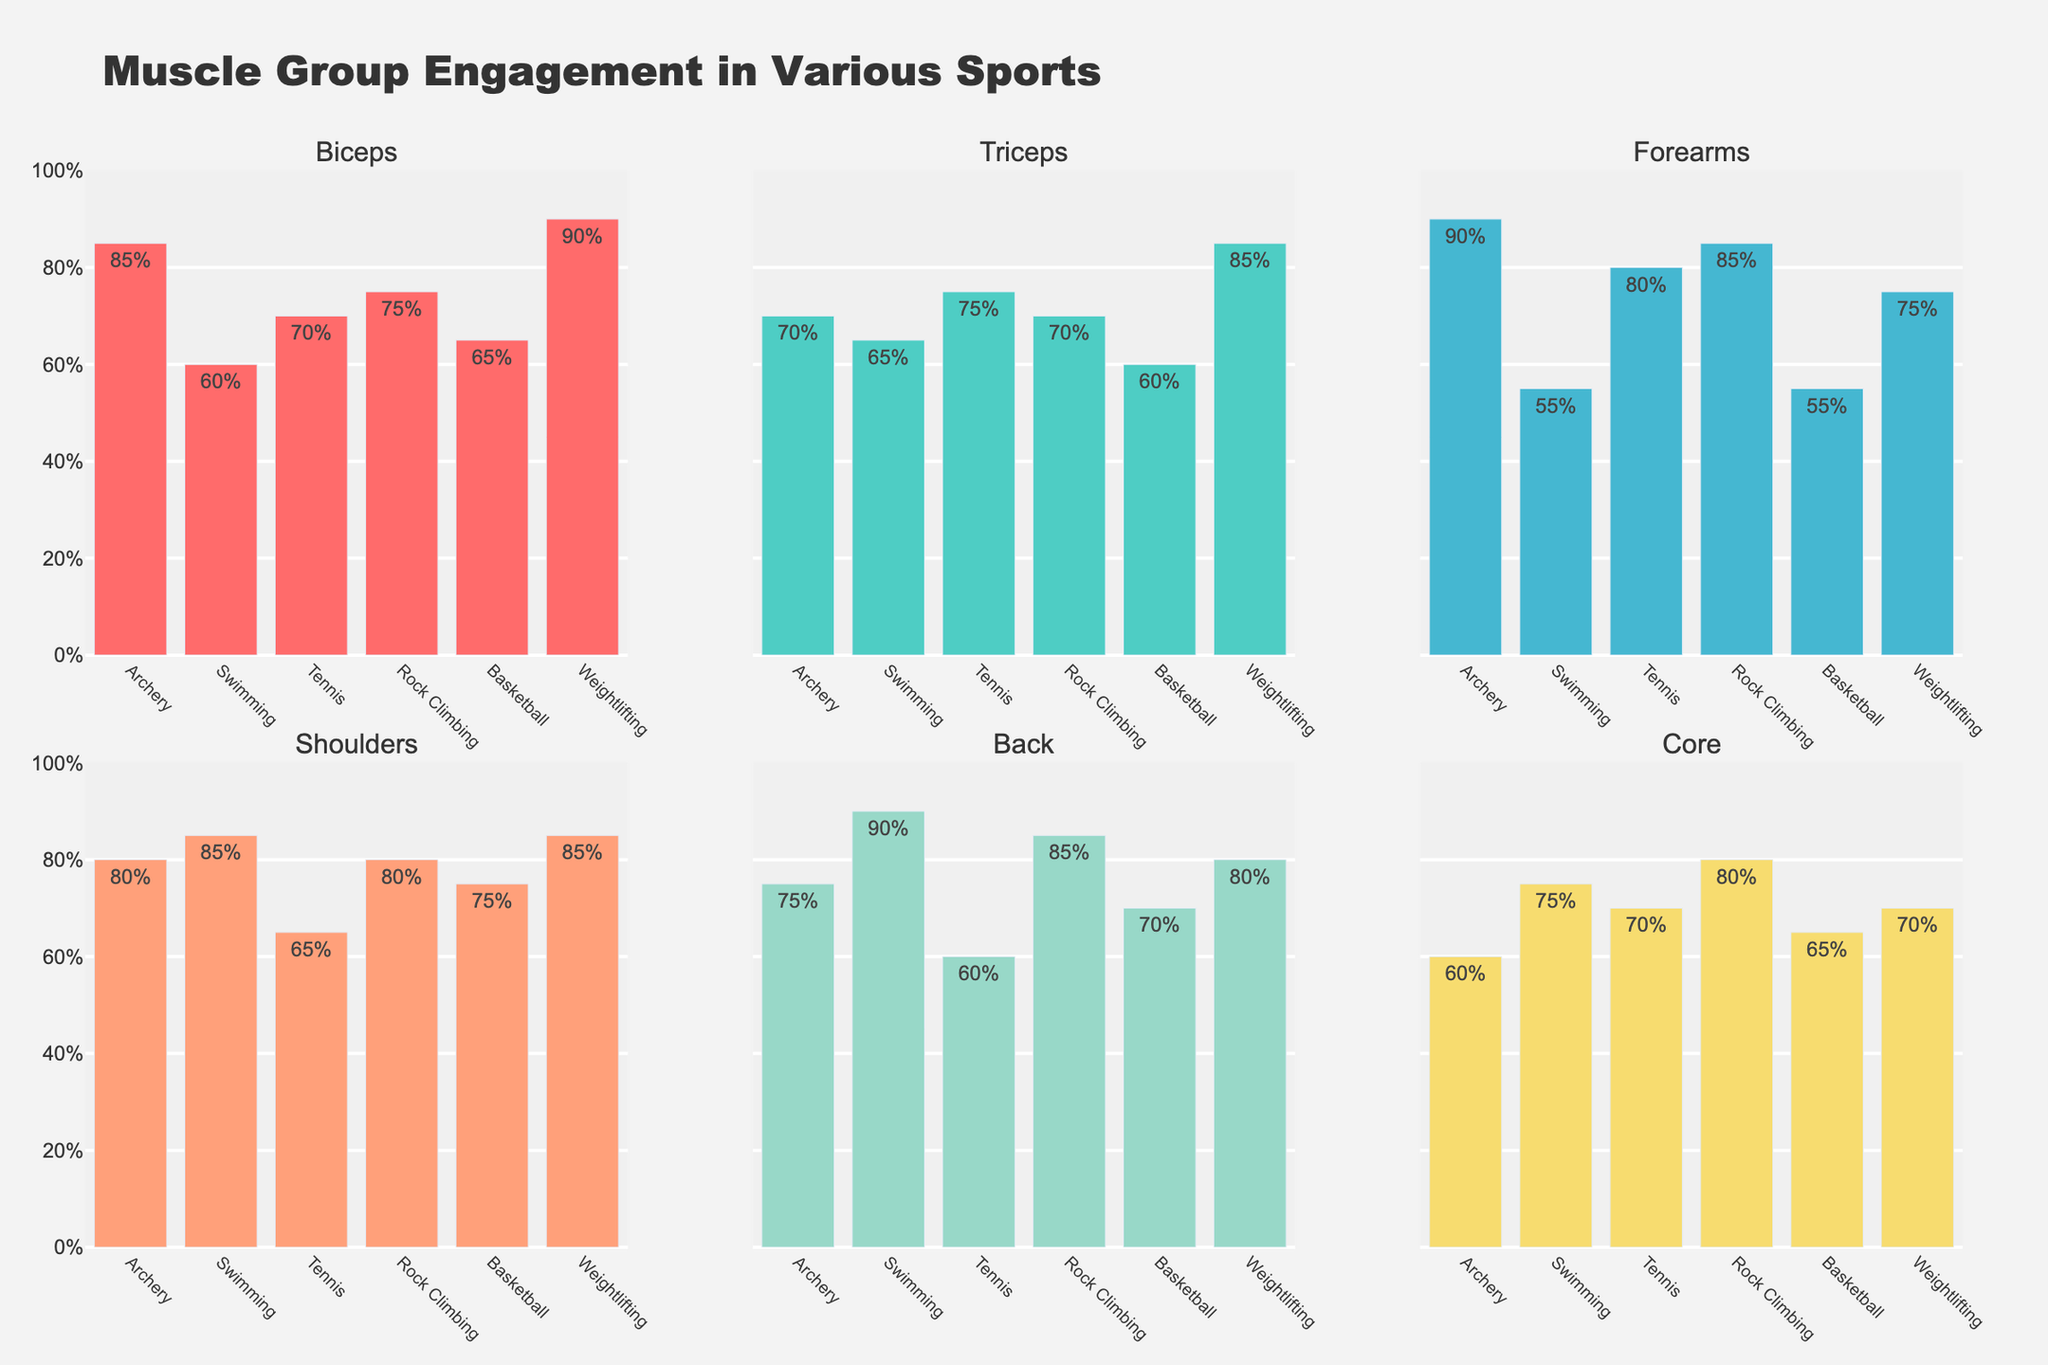What is the title of the figure? The title is located at the top center of the figure, it reads "Weekly Training Regimen for Professional Ballet Dancers"
Answer: Weekly Training Regimen for Professional Ballet Dancers Which activity has the highest number of hours on Wednesday? By observing the bars for Wednesday across the subplots, the Performance subplot shows the highest bar, representing 2 hours.
Answer: Performance What is the total hours spent on Conditioning throughout the week? Each subplot displays the hours spent on each activity per day. Adding up all the hours for Conditioning from Monday to Sunday gives 1 + 1.5 + 1 + 1.5 + 1 + 0.5 + 1 = 7.5 hours.
Answer: 7.5 hours How do the hours spent on Technique Class and Rest compare on Sunday? The subplot for Sunday shows 0 hours for Technique Class and 7 hours in the Rest subplot.
Answer: Technique Class: 0 hours, Rest: 7 hours Which day has the most balanced distribution of training activities, excluding Rest? One way to determine balance is to observe the subplots to see if all bars are approximately the same height. Thursday shows a relatively balanced distribution with similar hours spent on Technique Class (2), Rehearsal (4), Conditioning (1.5), and no Performance hours.
Answer: Thursday On which day are Rehearsal hours greater than Performance hours? By examining the subplots for each day, Monday, Tuesday, Thursday, Friday, and Saturday all show Rehearsal hours greater than Performance hours.
Answer: Monday, Tuesday, Thursday, Friday, Saturday What is the shortest duration of Technique Class and on which day does it occur? The subplot for Technique Class shows the shortest bar on Saturday with 1.5 hours.
Answer: 1.5 hours on Saturday How many hours in total are spent on Performance during the entire week? Summing up the Performance hours from each day results in 2 + 3 + 3 = 8 hours.
Answer: 8 hours Which activity is given the least amount of focus on Saturday? By examining all the subplots for activities on Saturday, Conditioning has the shortest bar with 0.5 hours.
Answer: Conditioning How do the hours spent on Rehearsal on Tuesday compare to those on Friday? The subplot for Rehearsal shows 5 hours on Tuesday and 3 hours on Friday.
Answer: 5 hours on Tuesday, 3 hours on Friday 